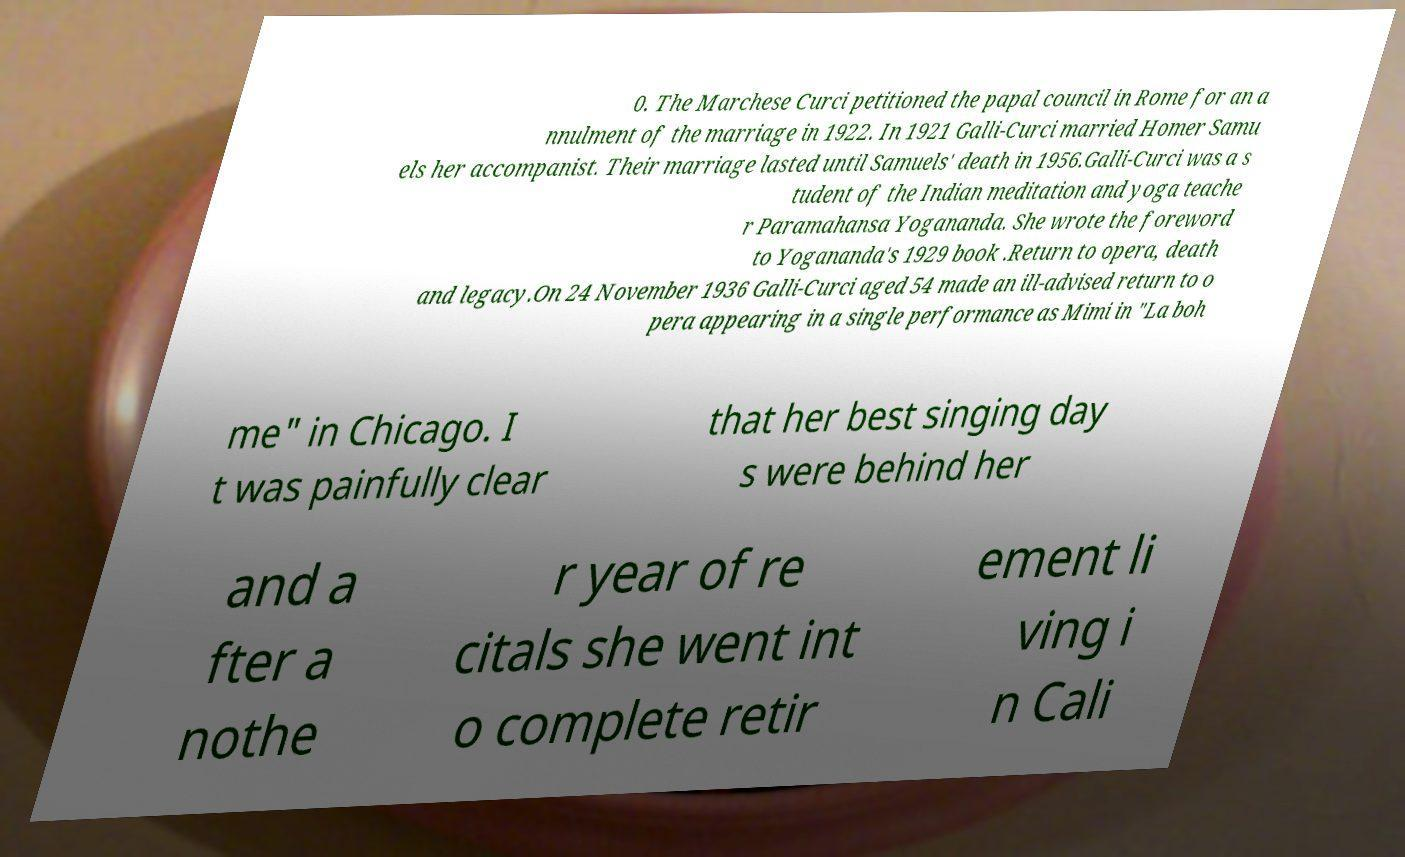Could you assist in decoding the text presented in this image and type it out clearly? 0. The Marchese Curci petitioned the papal council in Rome for an a nnulment of the marriage in 1922. In 1921 Galli-Curci married Homer Samu els her accompanist. Their marriage lasted until Samuels' death in 1956.Galli-Curci was a s tudent of the Indian meditation and yoga teache r Paramahansa Yogananda. She wrote the foreword to Yogananda's 1929 book .Return to opera, death and legacy.On 24 November 1936 Galli-Curci aged 54 made an ill-advised return to o pera appearing in a single performance as Mimi in "La boh me" in Chicago. I t was painfully clear that her best singing day s were behind her and a fter a nothe r year of re citals she went int o complete retir ement li ving i n Cali 